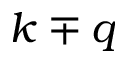Convert formula to latex. <formula><loc_0><loc_0><loc_500><loc_500>k \mp q</formula> 